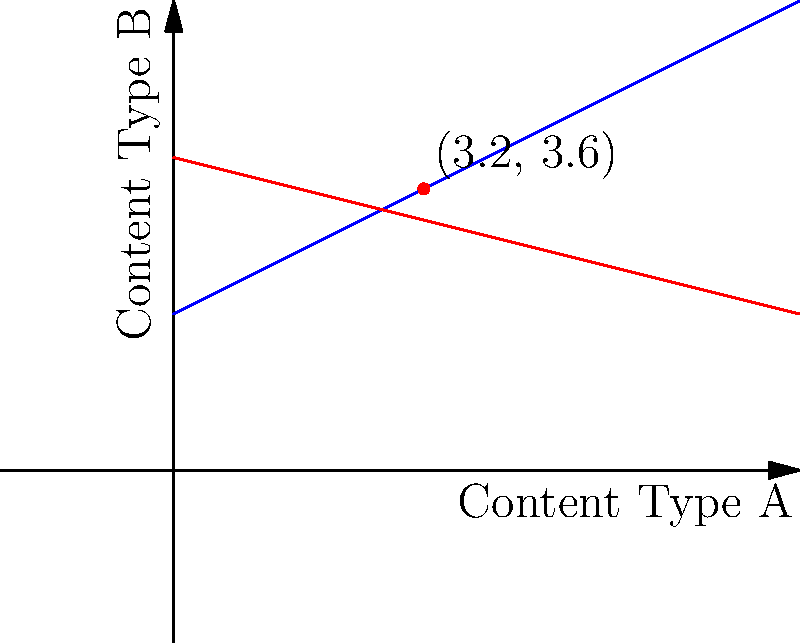On TikTok, two content trends are represented by linear equations. Trend 1 is given by $y = 0.5x + 2$, and Trend 2 is given by $y = -0.25x + 4$, where $x$ represents Content Type A and $y$ represents Content Type B. At what point do these trends intersect, potentially indicating an optimal content strategy for maximum engagement? To find the intersection point of the two trend lines, we need to solve the system of equations:

1) $y = 0.5x + 2$ (Trend 1)
2) $y = -0.25x + 4$ (Trend 2)

At the intersection point, both equations are true. So we can set them equal to each other:

3) $0.5x + 2 = -0.25x + 4$

Now, let's solve for $x$:

4) $0.5x + 0.25x = 4 - 2$
5) $0.75x = 2$
6) $x = \frac{2}{0.75} = \frac{8}{3} \approx 2.67$

To find $y$, we can substitute this $x$ value into either of the original equations. Let's use Trend 1:

7) $y = 0.5(\frac{8}{3}) + 2$
8) $y = \frac{4}{3} + 2 = \frac{10}{3} \approx 3.33$

Therefore, the intersection point is $(\frac{8}{3}, \frac{10}{3})$, or approximately $(2.67, 3.33)$.

To be more precise, we can express this as a fraction:

$x = \frac{8}{3} = 2.6666...$
$y = \frac{10}{3} = 3.3333...$

Rounded to one decimal place, the intersection point is $(2.7, 3.3)$.
Answer: $(2.7, 3.3)$ 